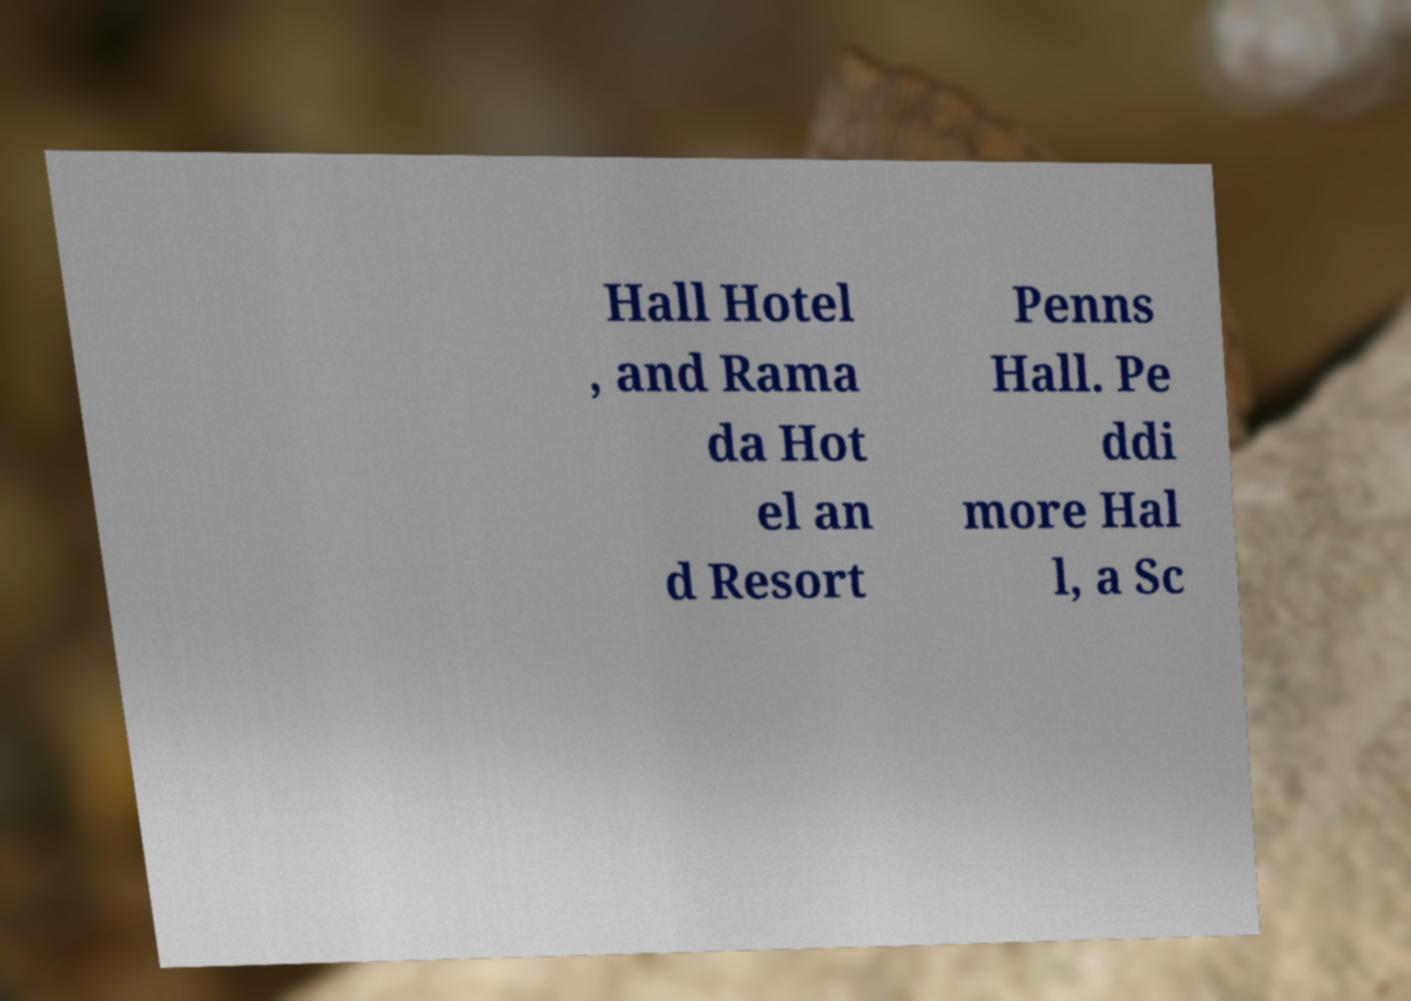What messages or text are displayed in this image? I need them in a readable, typed format. Hall Hotel , and Rama da Hot el an d Resort Penns Hall. Pe ddi more Hal l, a Sc 